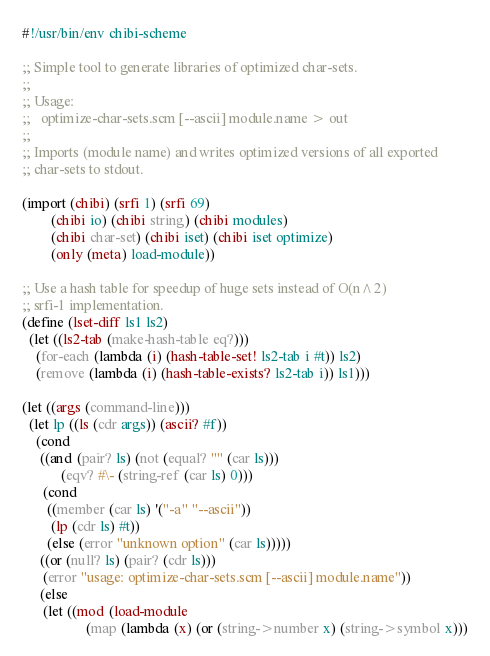Convert code to text. <code><loc_0><loc_0><loc_500><loc_500><_Scheme_>#!/usr/bin/env chibi-scheme

;; Simple tool to generate libraries of optimized char-sets.
;;
;; Usage:
;;   optimize-char-sets.scm [--ascii] module.name > out
;;
;; Imports (module name) and writes optimized versions of all exported
;; char-sets to stdout.

(import (chibi) (srfi 1) (srfi 69)
        (chibi io) (chibi string) (chibi modules)
        (chibi char-set) (chibi iset) (chibi iset optimize)
        (only (meta) load-module))

;; Use a hash table for speedup of huge sets instead of O(n^2)
;; srfi-1 implementation.
(define (lset-diff ls1 ls2)
  (let ((ls2-tab (make-hash-table eq?)))
    (for-each (lambda (i) (hash-table-set! ls2-tab i #t)) ls2)
    (remove (lambda (i) (hash-table-exists? ls2-tab i)) ls1)))

(let ((args (command-line)))
  (let lp ((ls (cdr args)) (ascii? #f))
    (cond
     ((and (pair? ls) (not (equal? "" (car ls)))
           (eqv? #\- (string-ref (car ls) 0)))
      (cond
       ((member (car ls) '("-a" "--ascii"))
        (lp (cdr ls) #t))
       (else (error "unknown option" (car ls)))))
     ((or (null? ls) (pair? (cdr ls)))
      (error "usage: optimize-char-sets.scm [--ascii] module.name"))
     (else
      (let ((mod (load-module
                  (map (lambda (x) (or (string->number x) (string->symbol x)))</code> 